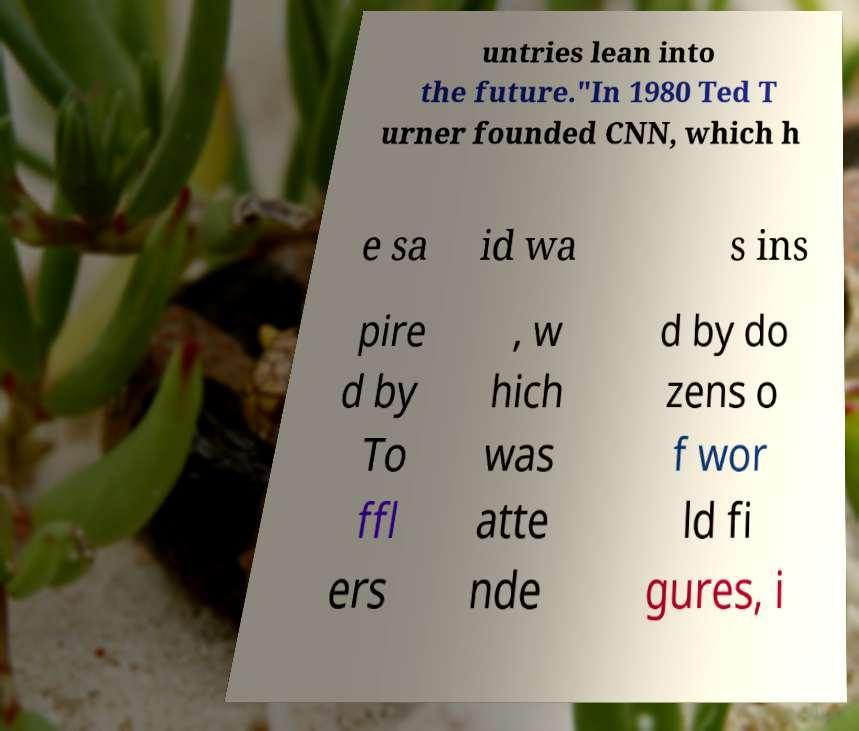Can you read and provide the text displayed in the image?This photo seems to have some interesting text. Can you extract and type it out for me? untries lean into the future."In 1980 Ted T urner founded CNN, which h e sa id wa s ins pire d by To ffl ers , w hich was atte nde d by do zens o f wor ld fi gures, i 